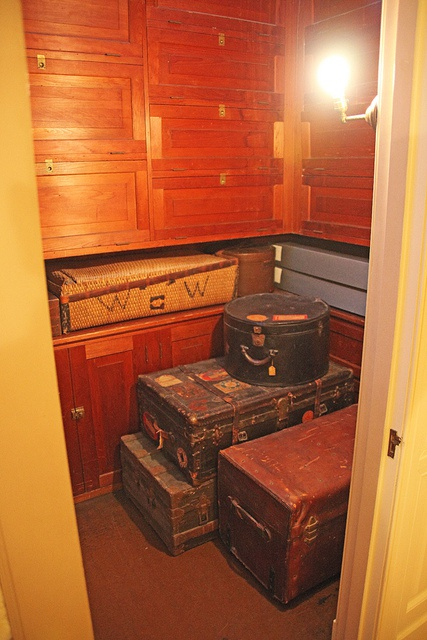Describe the objects in this image and their specific colors. I can see suitcase in orange, maroon, black, and brown tones, suitcase in orange, red, brown, and maroon tones, and suitcase in orange, maroon, black, and brown tones in this image. 